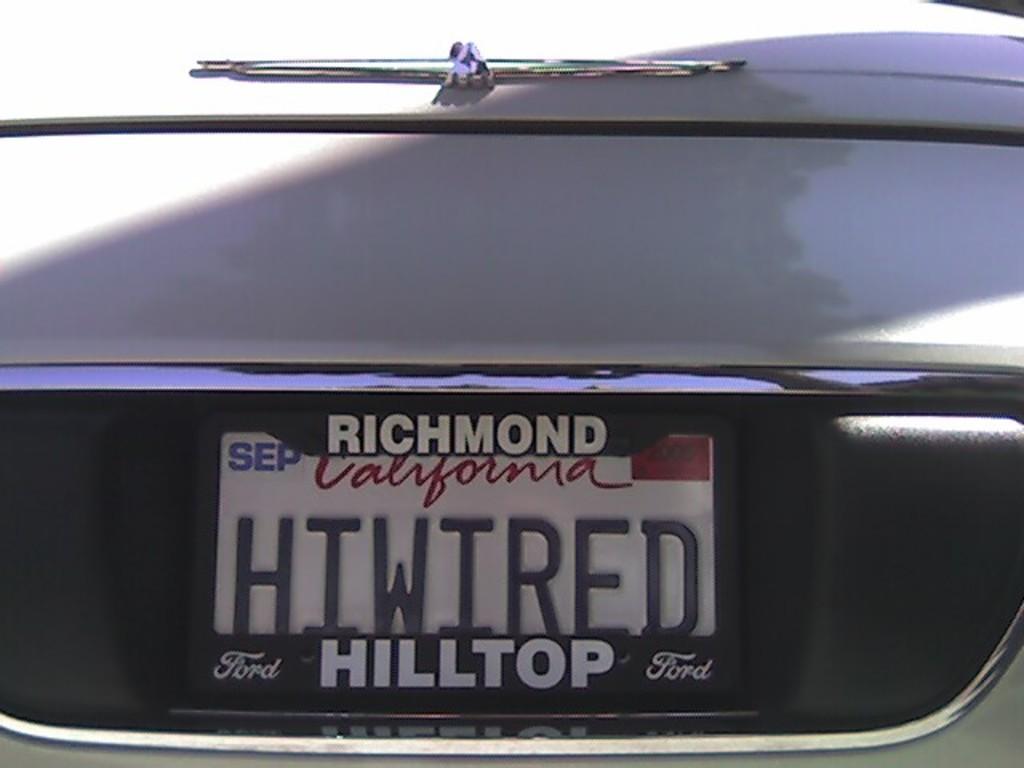What do the plates say?
Offer a very short reply. Hiwired. What brand of car is that?
Offer a very short reply. Ford. 